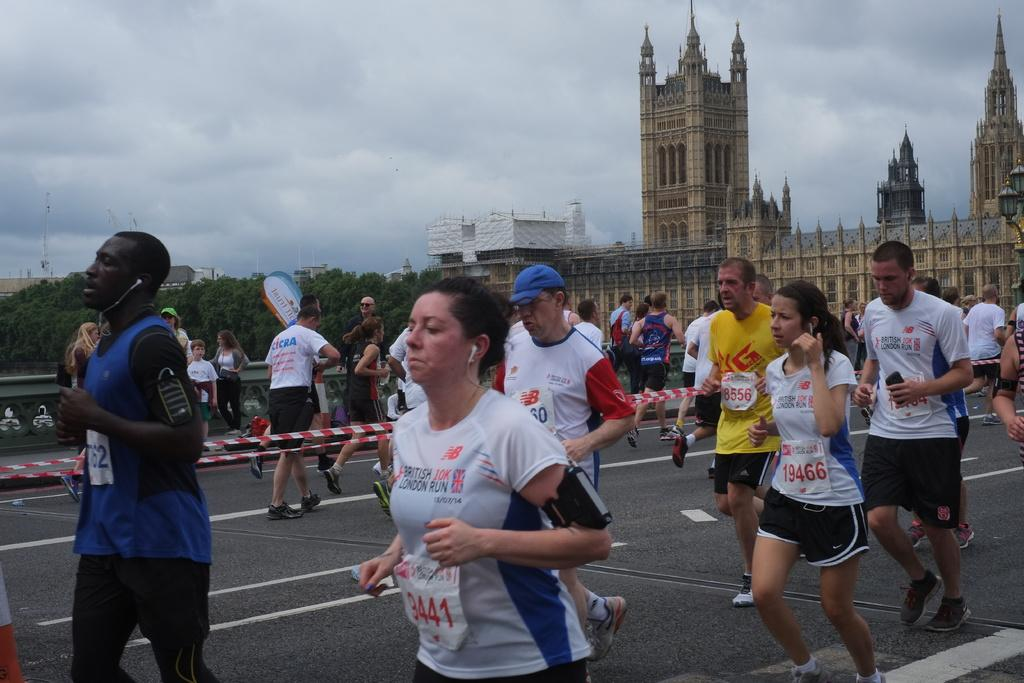Who or what can be seen in the image? There are people in the image. What structures are visible in the image? There are buildings in the image. What type of vegetation is present in the image? There are trees in the image. What other objects can be seen in the image? There are poles and ribbons in the image. What part of the natural environment is visible in the image? The sky and the ground are visible in the image. What is the condition of the sky in the image? The sky is visible with clouds in the image. What type of plantation can be seen in the image? There is no plantation present in the image. What rod is being used to cover the people in the image? There is no rod or covering visible in the image; the people are not being covered by any object. 